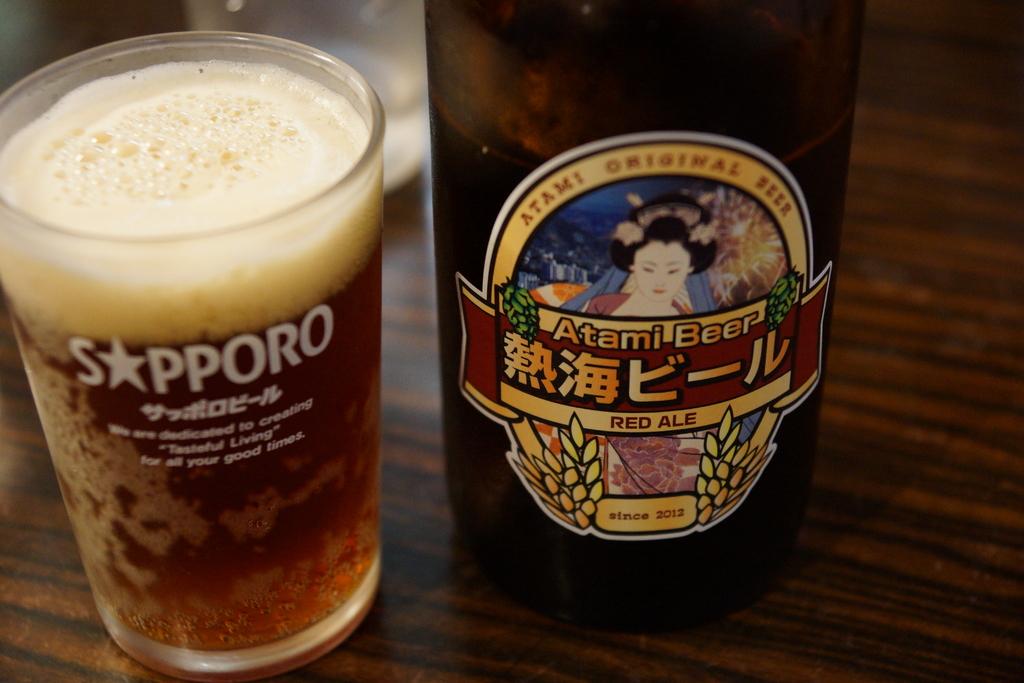What type of alcohol is this can?
Ensure brevity in your answer.  Red ale. What does the cup say?
Keep it short and to the point. Sapporo. 